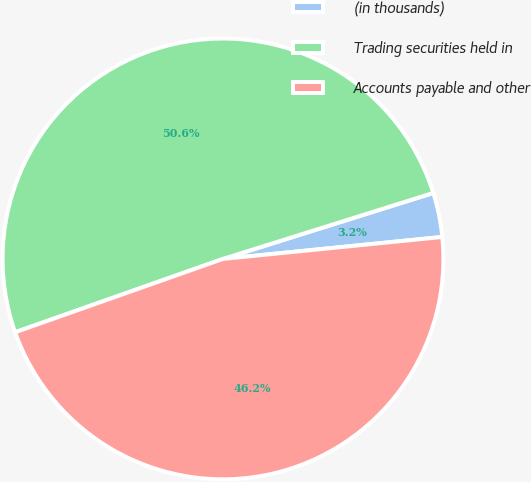Convert chart to OTSL. <chart><loc_0><loc_0><loc_500><loc_500><pie_chart><fcel>(in thousands)<fcel>Trading securities held in<fcel>Accounts payable and other<nl><fcel>3.25%<fcel>50.56%<fcel>46.19%<nl></chart> 